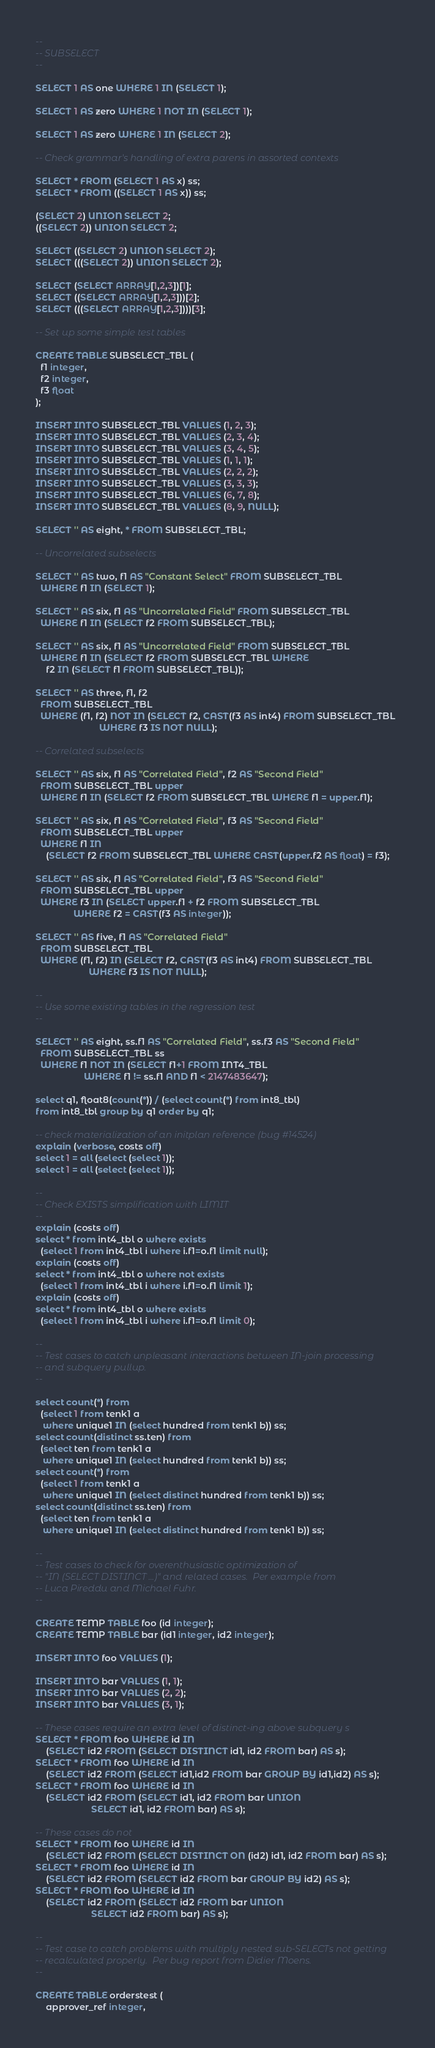Convert code to text. <code><loc_0><loc_0><loc_500><loc_500><_SQL_>--
-- SUBSELECT
--

SELECT 1 AS one WHERE 1 IN (SELECT 1);

SELECT 1 AS zero WHERE 1 NOT IN (SELECT 1);

SELECT 1 AS zero WHERE 1 IN (SELECT 2);

-- Check grammar's handling of extra parens in assorted contexts

SELECT * FROM (SELECT 1 AS x) ss;
SELECT * FROM ((SELECT 1 AS x)) ss;

(SELECT 2) UNION SELECT 2;
((SELECT 2)) UNION SELECT 2;

SELECT ((SELECT 2) UNION SELECT 2);
SELECT (((SELECT 2)) UNION SELECT 2);

SELECT (SELECT ARRAY[1,2,3])[1];
SELECT ((SELECT ARRAY[1,2,3]))[2];
SELECT (((SELECT ARRAY[1,2,3])))[3];

-- Set up some simple test tables

CREATE TABLE SUBSELECT_TBL (
  f1 integer,
  f2 integer,
  f3 float
);

INSERT INTO SUBSELECT_TBL VALUES (1, 2, 3);
INSERT INTO SUBSELECT_TBL VALUES (2, 3, 4);
INSERT INTO SUBSELECT_TBL VALUES (3, 4, 5);
INSERT INTO SUBSELECT_TBL VALUES (1, 1, 1);
INSERT INTO SUBSELECT_TBL VALUES (2, 2, 2);
INSERT INTO SUBSELECT_TBL VALUES (3, 3, 3);
INSERT INTO SUBSELECT_TBL VALUES (6, 7, 8);
INSERT INTO SUBSELECT_TBL VALUES (8, 9, NULL);

SELECT '' AS eight, * FROM SUBSELECT_TBL;

-- Uncorrelated subselects

SELECT '' AS two, f1 AS "Constant Select" FROM SUBSELECT_TBL
  WHERE f1 IN (SELECT 1);

SELECT '' AS six, f1 AS "Uncorrelated Field" FROM SUBSELECT_TBL
  WHERE f1 IN (SELECT f2 FROM SUBSELECT_TBL);

SELECT '' AS six, f1 AS "Uncorrelated Field" FROM SUBSELECT_TBL
  WHERE f1 IN (SELECT f2 FROM SUBSELECT_TBL WHERE
    f2 IN (SELECT f1 FROM SUBSELECT_TBL));

SELECT '' AS three, f1, f2
  FROM SUBSELECT_TBL
  WHERE (f1, f2) NOT IN (SELECT f2, CAST(f3 AS int4) FROM SUBSELECT_TBL
                         WHERE f3 IS NOT NULL);

-- Correlated subselects

SELECT '' AS six, f1 AS "Correlated Field", f2 AS "Second Field"
  FROM SUBSELECT_TBL upper
  WHERE f1 IN (SELECT f2 FROM SUBSELECT_TBL WHERE f1 = upper.f1);

SELECT '' AS six, f1 AS "Correlated Field", f3 AS "Second Field"
  FROM SUBSELECT_TBL upper
  WHERE f1 IN
    (SELECT f2 FROM SUBSELECT_TBL WHERE CAST(upper.f2 AS float) = f3);

SELECT '' AS six, f1 AS "Correlated Field", f3 AS "Second Field"
  FROM SUBSELECT_TBL upper
  WHERE f3 IN (SELECT upper.f1 + f2 FROM SUBSELECT_TBL
               WHERE f2 = CAST(f3 AS integer));

SELECT '' AS five, f1 AS "Correlated Field"
  FROM SUBSELECT_TBL
  WHERE (f1, f2) IN (SELECT f2, CAST(f3 AS int4) FROM SUBSELECT_TBL
                     WHERE f3 IS NOT NULL);

--
-- Use some existing tables in the regression test
--

SELECT '' AS eight, ss.f1 AS "Correlated Field", ss.f3 AS "Second Field"
  FROM SUBSELECT_TBL ss
  WHERE f1 NOT IN (SELECT f1+1 FROM INT4_TBL
                   WHERE f1 != ss.f1 AND f1 < 2147483647);

select q1, float8(count(*)) / (select count(*) from int8_tbl)
from int8_tbl group by q1 order by q1;

-- check materialization of an initplan reference (bug #14524)
explain (verbose, costs off)
select 1 = all (select (select 1));
select 1 = all (select (select 1));

--
-- Check EXISTS simplification with LIMIT
--
explain (costs off)
select * from int4_tbl o where exists
  (select 1 from int4_tbl i where i.f1=o.f1 limit null);
explain (costs off)
select * from int4_tbl o where not exists
  (select 1 from int4_tbl i where i.f1=o.f1 limit 1);
explain (costs off)
select * from int4_tbl o where exists
  (select 1 from int4_tbl i where i.f1=o.f1 limit 0);

--
-- Test cases to catch unpleasant interactions between IN-join processing
-- and subquery pullup.
--

select count(*) from
  (select 1 from tenk1 a
   where unique1 IN (select hundred from tenk1 b)) ss;
select count(distinct ss.ten) from
  (select ten from tenk1 a
   where unique1 IN (select hundred from tenk1 b)) ss;
select count(*) from
  (select 1 from tenk1 a
   where unique1 IN (select distinct hundred from tenk1 b)) ss;
select count(distinct ss.ten) from
  (select ten from tenk1 a
   where unique1 IN (select distinct hundred from tenk1 b)) ss;

--
-- Test cases to check for overenthusiastic optimization of
-- "IN (SELECT DISTINCT ...)" and related cases.  Per example from
-- Luca Pireddu and Michael Fuhr.
--

CREATE TEMP TABLE foo (id integer);
CREATE TEMP TABLE bar (id1 integer, id2 integer);

INSERT INTO foo VALUES (1);

INSERT INTO bar VALUES (1, 1);
INSERT INTO bar VALUES (2, 2);
INSERT INTO bar VALUES (3, 1);

-- These cases require an extra level of distinct-ing above subquery s
SELECT * FROM foo WHERE id IN
    (SELECT id2 FROM (SELECT DISTINCT id1, id2 FROM bar) AS s);
SELECT * FROM foo WHERE id IN
    (SELECT id2 FROM (SELECT id1,id2 FROM bar GROUP BY id1,id2) AS s);
SELECT * FROM foo WHERE id IN
    (SELECT id2 FROM (SELECT id1, id2 FROM bar UNION
                      SELECT id1, id2 FROM bar) AS s);

-- These cases do not
SELECT * FROM foo WHERE id IN
    (SELECT id2 FROM (SELECT DISTINCT ON (id2) id1, id2 FROM bar) AS s);
SELECT * FROM foo WHERE id IN
    (SELECT id2 FROM (SELECT id2 FROM bar GROUP BY id2) AS s);
SELECT * FROM foo WHERE id IN
    (SELECT id2 FROM (SELECT id2 FROM bar UNION
                      SELECT id2 FROM bar) AS s);

--
-- Test case to catch problems with multiply nested sub-SELECTs not getting
-- recalculated properly.  Per bug report from Didier Moens.
--

CREATE TABLE orderstest (
    approver_ref integer,</code> 